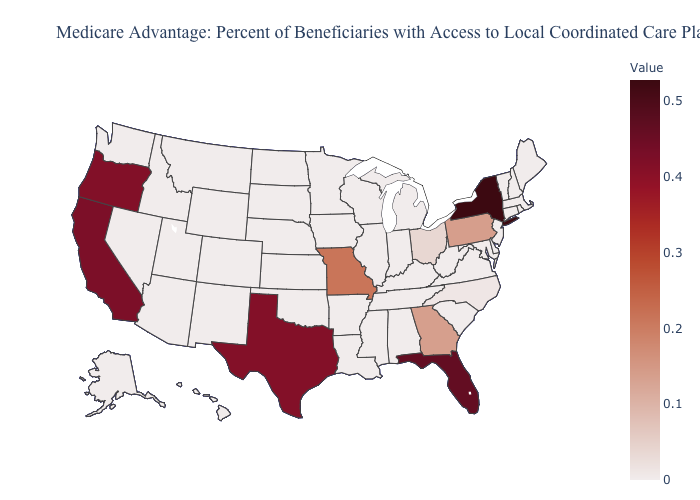Does the map have missing data?
Write a very short answer. No. Among the states that border North Dakota , which have the lowest value?
Answer briefly. Minnesota, Montana, South Dakota. Among the states that border Massachusetts , does New York have the highest value?
Concise answer only. Yes. Does Massachusetts have the highest value in the Northeast?
Answer briefly. No. Does Idaho have the lowest value in the USA?
Give a very brief answer. Yes. 